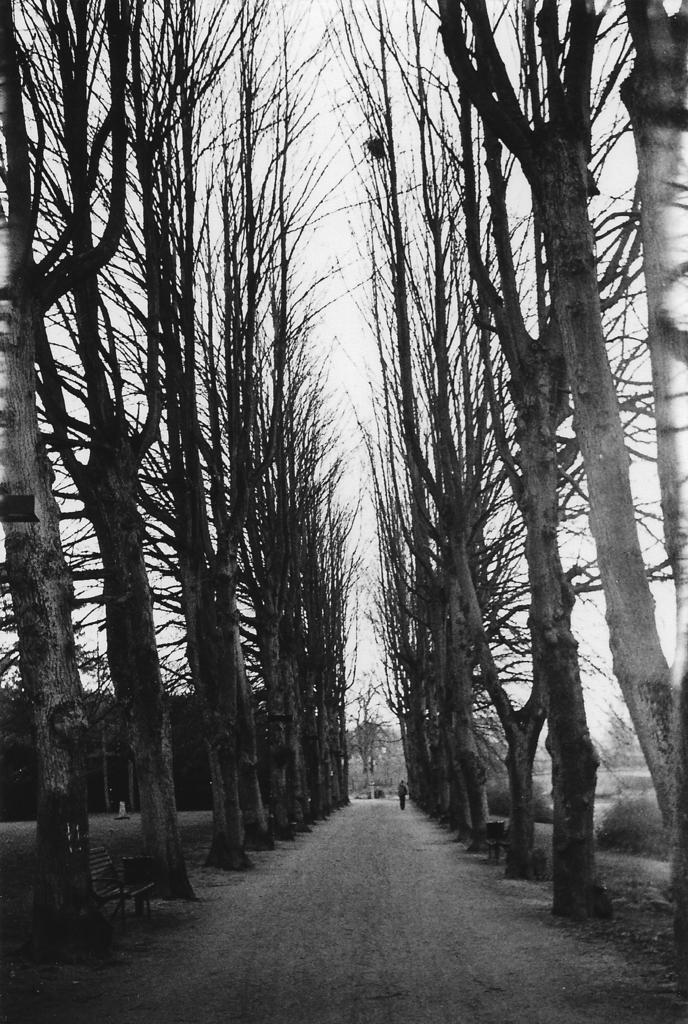What is the color scheme of the image? The image is black and white. What type of natural elements can be seen in the image? There are trees in the image. What type of seating is present in the image? There is a bench in the image. Who or what is present in the image? There is a person in the image. What type of man-made structure is visible in the image? There is a road at the bottom of the image. What is visible at the top of the image? There is sky visible at the top of the image. What type of maid is cleaning the clouds in the image? There are no clouds or maids present in the image; it is a black and white image featuring trees, a bench, a person, a road, and sky. 